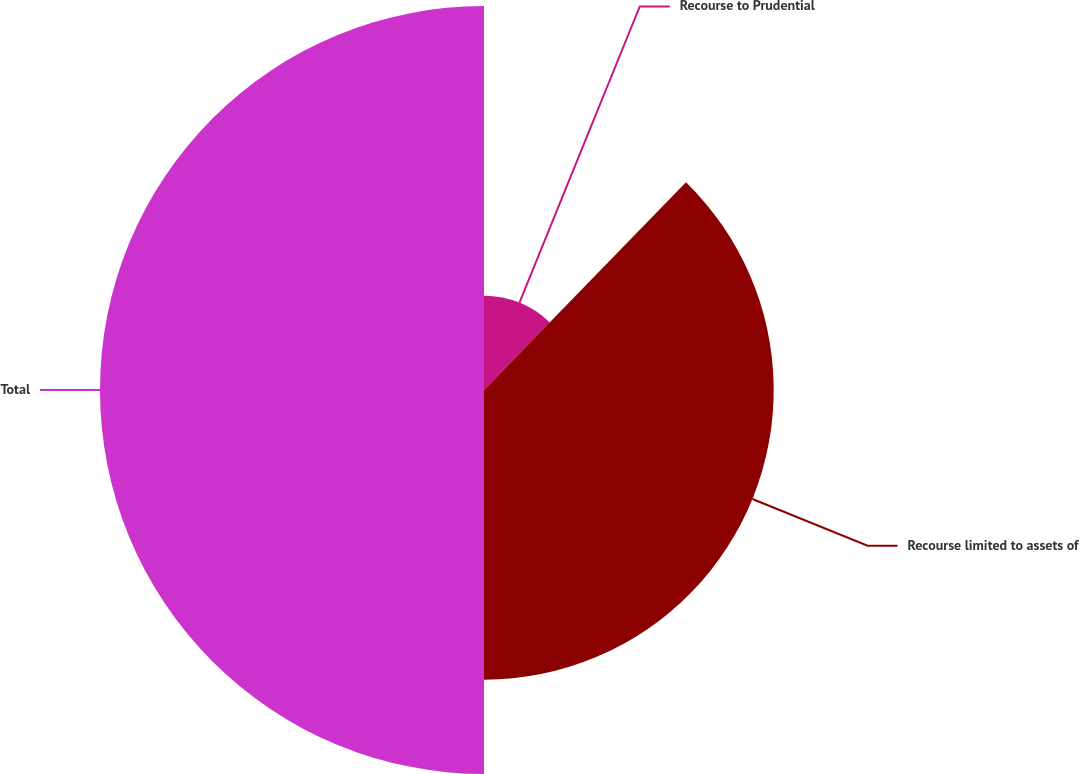Convert chart to OTSL. <chart><loc_0><loc_0><loc_500><loc_500><pie_chart><fcel>Recourse to Prudential<fcel>Recourse limited to assets of<fcel>Total<nl><fcel>12.28%<fcel>37.72%<fcel>50.0%<nl></chart> 